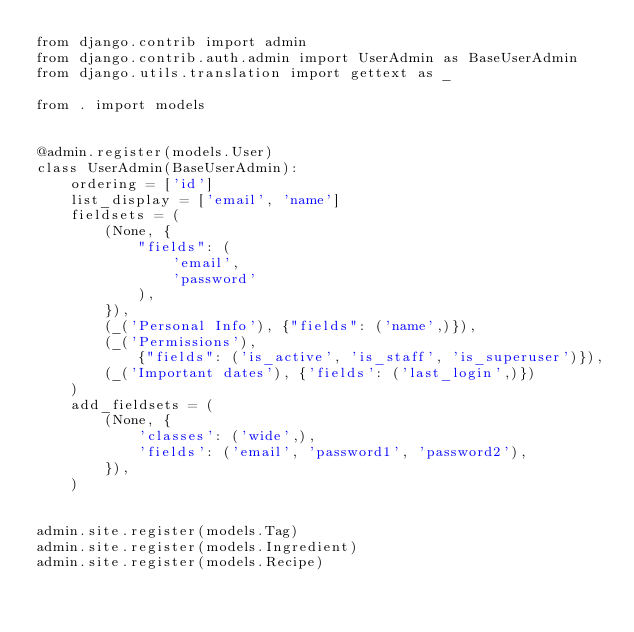<code> <loc_0><loc_0><loc_500><loc_500><_Python_>from django.contrib import admin
from django.contrib.auth.admin import UserAdmin as BaseUserAdmin
from django.utils.translation import gettext as _

from . import models


@admin.register(models.User)
class UserAdmin(BaseUserAdmin):
    ordering = ['id']
    list_display = ['email', 'name']
    fieldsets = (
        (None, {
            "fields": (
                'email',
                'password'
            ),
        }),
        (_('Personal Info'), {"fields": ('name',)}),
        (_('Permissions'),
            {"fields": ('is_active', 'is_staff', 'is_superuser')}),
        (_('Important dates'), {'fields': ('last_login',)})
    )
    add_fieldsets = (
        (None, {
            'classes': ('wide',),
            'fields': ('email', 'password1', 'password2'),
        }),
    )


admin.site.register(models.Tag)
admin.site.register(models.Ingredient)
admin.site.register(models.Recipe)
</code> 